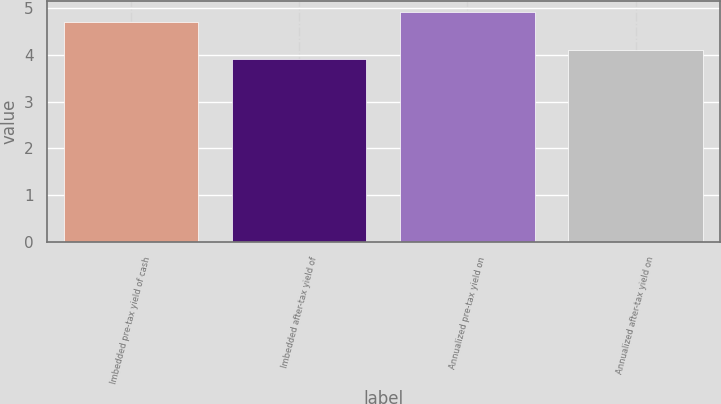Convert chart. <chart><loc_0><loc_0><loc_500><loc_500><bar_chart><fcel>Imbedded pre-tax yield of cash<fcel>Imbedded after-tax yield of<fcel>Annualized pre-tax yield on<fcel>Annualized after-tax yield on<nl><fcel>4.7<fcel>3.9<fcel>4.9<fcel>4.1<nl></chart> 